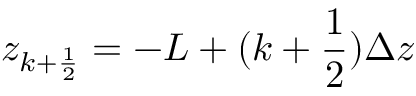Convert formula to latex. <formula><loc_0><loc_0><loc_500><loc_500>z _ { k + \frac { 1 } { 2 } } = - L + ( k + \frac { 1 } { 2 } ) \Delta z</formula> 